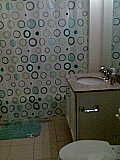Describe the objects in this image and their specific colors. I can see toilet in gray and black tones and sink in gray and black tones in this image. 